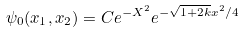<formula> <loc_0><loc_0><loc_500><loc_500>\psi _ { 0 } ( x _ { 1 } , x _ { 2 } ) = C e ^ { - X ^ { 2 } } e ^ { - \sqrt { 1 + 2 k } x ^ { 2 } / 4 }</formula> 